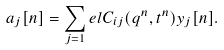<formula> <loc_0><loc_0><loc_500><loc_500>a _ { j } [ n ] = \sum _ { j = 1 } ^ { \ } e l C _ { i j } ( q ^ { n } , t ^ { n } ) y _ { j } [ n ] .</formula> 